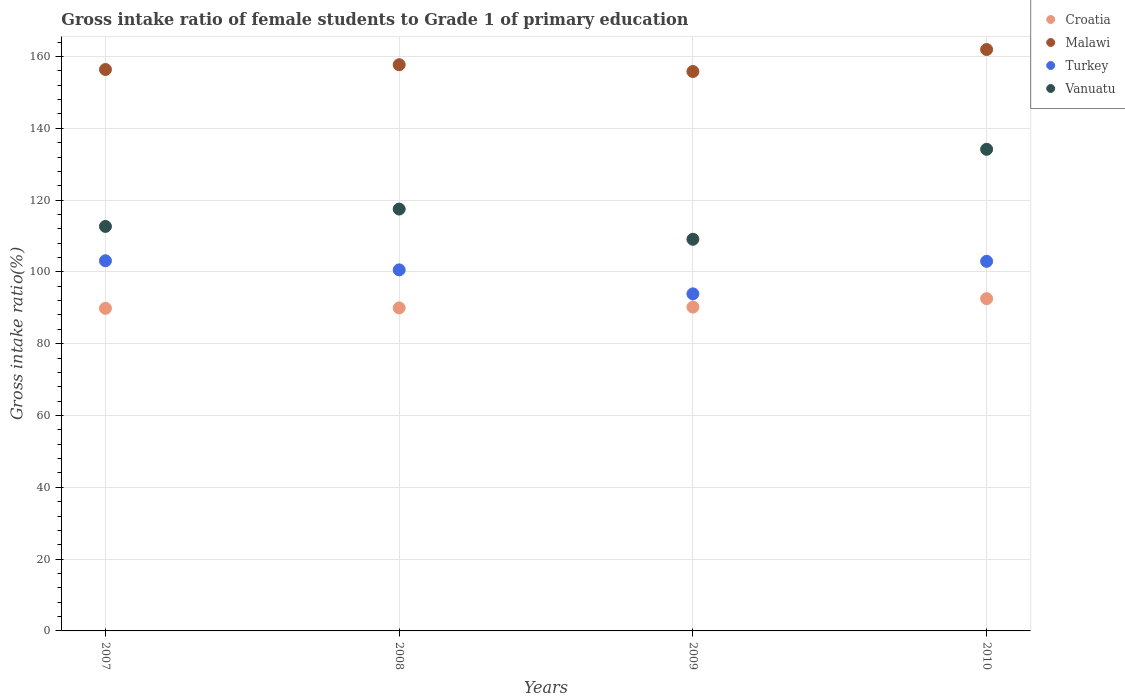What is the gross intake ratio in Vanuatu in 2007?
Your response must be concise. 112.67. Across all years, what is the maximum gross intake ratio in Turkey?
Ensure brevity in your answer.  103.11. Across all years, what is the minimum gross intake ratio in Vanuatu?
Your answer should be very brief. 109.09. What is the total gross intake ratio in Vanuatu in the graph?
Offer a terse response. 473.42. What is the difference between the gross intake ratio in Turkey in 2008 and that in 2010?
Provide a succinct answer. -2.38. What is the difference between the gross intake ratio in Croatia in 2009 and the gross intake ratio in Malawi in 2007?
Ensure brevity in your answer.  -66.18. What is the average gross intake ratio in Turkey per year?
Your answer should be very brief. 100.13. In the year 2007, what is the difference between the gross intake ratio in Malawi and gross intake ratio in Vanuatu?
Offer a very short reply. 43.71. What is the ratio of the gross intake ratio in Malawi in 2007 to that in 2010?
Ensure brevity in your answer.  0.97. Is the gross intake ratio in Vanuatu in 2008 less than that in 2009?
Make the answer very short. No. Is the difference between the gross intake ratio in Malawi in 2008 and 2009 greater than the difference between the gross intake ratio in Vanuatu in 2008 and 2009?
Give a very brief answer. No. What is the difference between the highest and the second highest gross intake ratio in Vanuatu?
Offer a very short reply. 16.64. What is the difference between the highest and the lowest gross intake ratio in Turkey?
Offer a terse response. 9.22. In how many years, is the gross intake ratio in Croatia greater than the average gross intake ratio in Croatia taken over all years?
Your answer should be very brief. 1. Is it the case that in every year, the sum of the gross intake ratio in Turkey and gross intake ratio in Malawi  is greater than the gross intake ratio in Croatia?
Provide a succinct answer. Yes. Does the gross intake ratio in Malawi monotonically increase over the years?
Your answer should be very brief. No. Is the gross intake ratio in Malawi strictly greater than the gross intake ratio in Croatia over the years?
Your answer should be very brief. Yes. Is the gross intake ratio in Vanuatu strictly less than the gross intake ratio in Croatia over the years?
Your answer should be compact. No. How many dotlines are there?
Provide a short and direct response. 4. How many years are there in the graph?
Offer a very short reply. 4. Are the values on the major ticks of Y-axis written in scientific E-notation?
Make the answer very short. No. Does the graph contain any zero values?
Give a very brief answer. No. How are the legend labels stacked?
Your answer should be very brief. Vertical. What is the title of the graph?
Your response must be concise. Gross intake ratio of female students to Grade 1 of primary education. What is the label or title of the X-axis?
Offer a very short reply. Years. What is the label or title of the Y-axis?
Your answer should be compact. Gross intake ratio(%). What is the Gross intake ratio(%) in Croatia in 2007?
Your response must be concise. 89.86. What is the Gross intake ratio(%) in Malawi in 2007?
Provide a short and direct response. 156.38. What is the Gross intake ratio(%) of Turkey in 2007?
Offer a terse response. 103.11. What is the Gross intake ratio(%) in Vanuatu in 2007?
Offer a very short reply. 112.67. What is the Gross intake ratio(%) of Croatia in 2008?
Provide a succinct answer. 89.97. What is the Gross intake ratio(%) in Malawi in 2008?
Ensure brevity in your answer.  157.71. What is the Gross intake ratio(%) of Turkey in 2008?
Offer a terse response. 100.57. What is the Gross intake ratio(%) in Vanuatu in 2008?
Provide a short and direct response. 117.51. What is the Gross intake ratio(%) in Croatia in 2009?
Offer a very short reply. 90.2. What is the Gross intake ratio(%) of Malawi in 2009?
Offer a very short reply. 155.82. What is the Gross intake ratio(%) of Turkey in 2009?
Provide a short and direct response. 93.89. What is the Gross intake ratio(%) in Vanuatu in 2009?
Give a very brief answer. 109.09. What is the Gross intake ratio(%) of Croatia in 2010?
Keep it short and to the point. 92.56. What is the Gross intake ratio(%) of Malawi in 2010?
Provide a short and direct response. 161.95. What is the Gross intake ratio(%) in Turkey in 2010?
Your response must be concise. 102.95. What is the Gross intake ratio(%) in Vanuatu in 2010?
Ensure brevity in your answer.  134.15. Across all years, what is the maximum Gross intake ratio(%) in Croatia?
Keep it short and to the point. 92.56. Across all years, what is the maximum Gross intake ratio(%) in Malawi?
Your response must be concise. 161.95. Across all years, what is the maximum Gross intake ratio(%) of Turkey?
Your response must be concise. 103.11. Across all years, what is the maximum Gross intake ratio(%) in Vanuatu?
Make the answer very short. 134.15. Across all years, what is the minimum Gross intake ratio(%) of Croatia?
Your answer should be compact. 89.86. Across all years, what is the minimum Gross intake ratio(%) in Malawi?
Keep it short and to the point. 155.82. Across all years, what is the minimum Gross intake ratio(%) in Turkey?
Make the answer very short. 93.89. Across all years, what is the minimum Gross intake ratio(%) of Vanuatu?
Keep it short and to the point. 109.09. What is the total Gross intake ratio(%) of Croatia in the graph?
Keep it short and to the point. 362.58. What is the total Gross intake ratio(%) of Malawi in the graph?
Offer a very short reply. 631.86. What is the total Gross intake ratio(%) of Turkey in the graph?
Offer a very short reply. 400.51. What is the total Gross intake ratio(%) of Vanuatu in the graph?
Keep it short and to the point. 473.42. What is the difference between the Gross intake ratio(%) of Croatia in 2007 and that in 2008?
Provide a short and direct response. -0.11. What is the difference between the Gross intake ratio(%) of Malawi in 2007 and that in 2008?
Give a very brief answer. -1.33. What is the difference between the Gross intake ratio(%) of Turkey in 2007 and that in 2008?
Keep it short and to the point. 2.54. What is the difference between the Gross intake ratio(%) of Vanuatu in 2007 and that in 2008?
Your response must be concise. -4.84. What is the difference between the Gross intake ratio(%) in Croatia in 2007 and that in 2009?
Make the answer very short. -0.34. What is the difference between the Gross intake ratio(%) of Malawi in 2007 and that in 2009?
Your answer should be compact. 0.56. What is the difference between the Gross intake ratio(%) of Turkey in 2007 and that in 2009?
Provide a succinct answer. 9.22. What is the difference between the Gross intake ratio(%) in Vanuatu in 2007 and that in 2009?
Offer a terse response. 3.58. What is the difference between the Gross intake ratio(%) of Croatia in 2007 and that in 2010?
Provide a succinct answer. -2.7. What is the difference between the Gross intake ratio(%) in Malawi in 2007 and that in 2010?
Keep it short and to the point. -5.56. What is the difference between the Gross intake ratio(%) in Turkey in 2007 and that in 2010?
Your answer should be very brief. 0.16. What is the difference between the Gross intake ratio(%) in Vanuatu in 2007 and that in 2010?
Ensure brevity in your answer.  -21.48. What is the difference between the Gross intake ratio(%) in Croatia in 2008 and that in 2009?
Offer a terse response. -0.24. What is the difference between the Gross intake ratio(%) in Malawi in 2008 and that in 2009?
Make the answer very short. 1.89. What is the difference between the Gross intake ratio(%) in Turkey in 2008 and that in 2009?
Ensure brevity in your answer.  6.68. What is the difference between the Gross intake ratio(%) in Vanuatu in 2008 and that in 2009?
Make the answer very short. 8.42. What is the difference between the Gross intake ratio(%) in Croatia in 2008 and that in 2010?
Offer a terse response. -2.59. What is the difference between the Gross intake ratio(%) of Malawi in 2008 and that in 2010?
Provide a succinct answer. -4.23. What is the difference between the Gross intake ratio(%) of Turkey in 2008 and that in 2010?
Offer a terse response. -2.38. What is the difference between the Gross intake ratio(%) in Vanuatu in 2008 and that in 2010?
Your answer should be compact. -16.64. What is the difference between the Gross intake ratio(%) in Croatia in 2009 and that in 2010?
Give a very brief answer. -2.35. What is the difference between the Gross intake ratio(%) of Malawi in 2009 and that in 2010?
Provide a succinct answer. -6.13. What is the difference between the Gross intake ratio(%) of Turkey in 2009 and that in 2010?
Provide a short and direct response. -9.06. What is the difference between the Gross intake ratio(%) in Vanuatu in 2009 and that in 2010?
Give a very brief answer. -25.07. What is the difference between the Gross intake ratio(%) of Croatia in 2007 and the Gross intake ratio(%) of Malawi in 2008?
Make the answer very short. -67.85. What is the difference between the Gross intake ratio(%) of Croatia in 2007 and the Gross intake ratio(%) of Turkey in 2008?
Your response must be concise. -10.71. What is the difference between the Gross intake ratio(%) in Croatia in 2007 and the Gross intake ratio(%) in Vanuatu in 2008?
Keep it short and to the point. -27.65. What is the difference between the Gross intake ratio(%) in Malawi in 2007 and the Gross intake ratio(%) in Turkey in 2008?
Your response must be concise. 55.82. What is the difference between the Gross intake ratio(%) in Malawi in 2007 and the Gross intake ratio(%) in Vanuatu in 2008?
Your response must be concise. 38.87. What is the difference between the Gross intake ratio(%) of Turkey in 2007 and the Gross intake ratio(%) of Vanuatu in 2008?
Give a very brief answer. -14.4. What is the difference between the Gross intake ratio(%) of Croatia in 2007 and the Gross intake ratio(%) of Malawi in 2009?
Provide a succinct answer. -65.96. What is the difference between the Gross intake ratio(%) in Croatia in 2007 and the Gross intake ratio(%) in Turkey in 2009?
Offer a very short reply. -4.03. What is the difference between the Gross intake ratio(%) in Croatia in 2007 and the Gross intake ratio(%) in Vanuatu in 2009?
Keep it short and to the point. -19.23. What is the difference between the Gross intake ratio(%) of Malawi in 2007 and the Gross intake ratio(%) of Turkey in 2009?
Keep it short and to the point. 62.49. What is the difference between the Gross intake ratio(%) in Malawi in 2007 and the Gross intake ratio(%) in Vanuatu in 2009?
Provide a succinct answer. 47.3. What is the difference between the Gross intake ratio(%) in Turkey in 2007 and the Gross intake ratio(%) in Vanuatu in 2009?
Your answer should be very brief. -5.98. What is the difference between the Gross intake ratio(%) in Croatia in 2007 and the Gross intake ratio(%) in Malawi in 2010?
Keep it short and to the point. -72.09. What is the difference between the Gross intake ratio(%) of Croatia in 2007 and the Gross intake ratio(%) of Turkey in 2010?
Provide a short and direct response. -13.09. What is the difference between the Gross intake ratio(%) of Croatia in 2007 and the Gross intake ratio(%) of Vanuatu in 2010?
Your answer should be very brief. -44.29. What is the difference between the Gross intake ratio(%) in Malawi in 2007 and the Gross intake ratio(%) in Turkey in 2010?
Your response must be concise. 53.43. What is the difference between the Gross intake ratio(%) of Malawi in 2007 and the Gross intake ratio(%) of Vanuatu in 2010?
Ensure brevity in your answer.  22.23. What is the difference between the Gross intake ratio(%) in Turkey in 2007 and the Gross intake ratio(%) in Vanuatu in 2010?
Offer a very short reply. -31.05. What is the difference between the Gross intake ratio(%) of Croatia in 2008 and the Gross intake ratio(%) of Malawi in 2009?
Keep it short and to the point. -65.85. What is the difference between the Gross intake ratio(%) of Croatia in 2008 and the Gross intake ratio(%) of Turkey in 2009?
Provide a short and direct response. -3.92. What is the difference between the Gross intake ratio(%) in Croatia in 2008 and the Gross intake ratio(%) in Vanuatu in 2009?
Keep it short and to the point. -19.12. What is the difference between the Gross intake ratio(%) of Malawi in 2008 and the Gross intake ratio(%) of Turkey in 2009?
Ensure brevity in your answer.  63.82. What is the difference between the Gross intake ratio(%) of Malawi in 2008 and the Gross intake ratio(%) of Vanuatu in 2009?
Offer a very short reply. 48.63. What is the difference between the Gross intake ratio(%) in Turkey in 2008 and the Gross intake ratio(%) in Vanuatu in 2009?
Provide a short and direct response. -8.52. What is the difference between the Gross intake ratio(%) in Croatia in 2008 and the Gross intake ratio(%) in Malawi in 2010?
Offer a very short reply. -71.98. What is the difference between the Gross intake ratio(%) of Croatia in 2008 and the Gross intake ratio(%) of Turkey in 2010?
Provide a short and direct response. -12.98. What is the difference between the Gross intake ratio(%) of Croatia in 2008 and the Gross intake ratio(%) of Vanuatu in 2010?
Keep it short and to the point. -44.19. What is the difference between the Gross intake ratio(%) of Malawi in 2008 and the Gross intake ratio(%) of Turkey in 2010?
Ensure brevity in your answer.  54.76. What is the difference between the Gross intake ratio(%) of Malawi in 2008 and the Gross intake ratio(%) of Vanuatu in 2010?
Your answer should be compact. 23.56. What is the difference between the Gross intake ratio(%) in Turkey in 2008 and the Gross intake ratio(%) in Vanuatu in 2010?
Keep it short and to the point. -33.59. What is the difference between the Gross intake ratio(%) of Croatia in 2009 and the Gross intake ratio(%) of Malawi in 2010?
Make the answer very short. -71.74. What is the difference between the Gross intake ratio(%) in Croatia in 2009 and the Gross intake ratio(%) in Turkey in 2010?
Your response must be concise. -12.75. What is the difference between the Gross intake ratio(%) in Croatia in 2009 and the Gross intake ratio(%) in Vanuatu in 2010?
Your answer should be very brief. -43.95. What is the difference between the Gross intake ratio(%) of Malawi in 2009 and the Gross intake ratio(%) of Turkey in 2010?
Ensure brevity in your answer.  52.87. What is the difference between the Gross intake ratio(%) in Malawi in 2009 and the Gross intake ratio(%) in Vanuatu in 2010?
Your answer should be very brief. 21.67. What is the difference between the Gross intake ratio(%) in Turkey in 2009 and the Gross intake ratio(%) in Vanuatu in 2010?
Your answer should be compact. -40.26. What is the average Gross intake ratio(%) of Croatia per year?
Make the answer very short. 90.65. What is the average Gross intake ratio(%) in Malawi per year?
Your answer should be very brief. 157.97. What is the average Gross intake ratio(%) in Turkey per year?
Offer a terse response. 100.13. What is the average Gross intake ratio(%) in Vanuatu per year?
Your answer should be compact. 118.36. In the year 2007, what is the difference between the Gross intake ratio(%) in Croatia and Gross intake ratio(%) in Malawi?
Ensure brevity in your answer.  -66.52. In the year 2007, what is the difference between the Gross intake ratio(%) of Croatia and Gross intake ratio(%) of Turkey?
Offer a terse response. -13.25. In the year 2007, what is the difference between the Gross intake ratio(%) in Croatia and Gross intake ratio(%) in Vanuatu?
Make the answer very short. -22.81. In the year 2007, what is the difference between the Gross intake ratio(%) of Malawi and Gross intake ratio(%) of Turkey?
Offer a terse response. 53.28. In the year 2007, what is the difference between the Gross intake ratio(%) in Malawi and Gross intake ratio(%) in Vanuatu?
Your response must be concise. 43.71. In the year 2007, what is the difference between the Gross intake ratio(%) in Turkey and Gross intake ratio(%) in Vanuatu?
Your answer should be compact. -9.57. In the year 2008, what is the difference between the Gross intake ratio(%) of Croatia and Gross intake ratio(%) of Malawi?
Provide a short and direct response. -67.75. In the year 2008, what is the difference between the Gross intake ratio(%) of Croatia and Gross intake ratio(%) of Turkey?
Offer a terse response. -10.6. In the year 2008, what is the difference between the Gross intake ratio(%) in Croatia and Gross intake ratio(%) in Vanuatu?
Your answer should be very brief. -27.54. In the year 2008, what is the difference between the Gross intake ratio(%) in Malawi and Gross intake ratio(%) in Turkey?
Offer a very short reply. 57.15. In the year 2008, what is the difference between the Gross intake ratio(%) in Malawi and Gross intake ratio(%) in Vanuatu?
Your answer should be compact. 40.2. In the year 2008, what is the difference between the Gross intake ratio(%) in Turkey and Gross intake ratio(%) in Vanuatu?
Give a very brief answer. -16.94. In the year 2009, what is the difference between the Gross intake ratio(%) in Croatia and Gross intake ratio(%) in Malawi?
Your answer should be very brief. -65.62. In the year 2009, what is the difference between the Gross intake ratio(%) in Croatia and Gross intake ratio(%) in Turkey?
Provide a short and direct response. -3.69. In the year 2009, what is the difference between the Gross intake ratio(%) in Croatia and Gross intake ratio(%) in Vanuatu?
Make the answer very short. -18.89. In the year 2009, what is the difference between the Gross intake ratio(%) in Malawi and Gross intake ratio(%) in Turkey?
Provide a succinct answer. 61.93. In the year 2009, what is the difference between the Gross intake ratio(%) in Malawi and Gross intake ratio(%) in Vanuatu?
Your answer should be very brief. 46.73. In the year 2009, what is the difference between the Gross intake ratio(%) in Turkey and Gross intake ratio(%) in Vanuatu?
Offer a terse response. -15.2. In the year 2010, what is the difference between the Gross intake ratio(%) of Croatia and Gross intake ratio(%) of Malawi?
Your answer should be very brief. -69.39. In the year 2010, what is the difference between the Gross intake ratio(%) in Croatia and Gross intake ratio(%) in Turkey?
Provide a short and direct response. -10.39. In the year 2010, what is the difference between the Gross intake ratio(%) in Croatia and Gross intake ratio(%) in Vanuatu?
Give a very brief answer. -41.6. In the year 2010, what is the difference between the Gross intake ratio(%) in Malawi and Gross intake ratio(%) in Turkey?
Provide a short and direct response. 59. In the year 2010, what is the difference between the Gross intake ratio(%) in Malawi and Gross intake ratio(%) in Vanuatu?
Offer a very short reply. 27.79. In the year 2010, what is the difference between the Gross intake ratio(%) in Turkey and Gross intake ratio(%) in Vanuatu?
Offer a very short reply. -31.2. What is the ratio of the Gross intake ratio(%) of Croatia in 2007 to that in 2008?
Your response must be concise. 1. What is the ratio of the Gross intake ratio(%) of Turkey in 2007 to that in 2008?
Your answer should be compact. 1.03. What is the ratio of the Gross intake ratio(%) of Vanuatu in 2007 to that in 2008?
Provide a succinct answer. 0.96. What is the ratio of the Gross intake ratio(%) of Malawi in 2007 to that in 2009?
Provide a short and direct response. 1. What is the ratio of the Gross intake ratio(%) in Turkey in 2007 to that in 2009?
Give a very brief answer. 1.1. What is the ratio of the Gross intake ratio(%) in Vanuatu in 2007 to that in 2009?
Ensure brevity in your answer.  1.03. What is the ratio of the Gross intake ratio(%) of Croatia in 2007 to that in 2010?
Keep it short and to the point. 0.97. What is the ratio of the Gross intake ratio(%) of Malawi in 2007 to that in 2010?
Offer a terse response. 0.97. What is the ratio of the Gross intake ratio(%) in Turkey in 2007 to that in 2010?
Offer a very short reply. 1. What is the ratio of the Gross intake ratio(%) in Vanuatu in 2007 to that in 2010?
Provide a short and direct response. 0.84. What is the ratio of the Gross intake ratio(%) in Croatia in 2008 to that in 2009?
Offer a terse response. 1. What is the ratio of the Gross intake ratio(%) of Malawi in 2008 to that in 2009?
Your response must be concise. 1.01. What is the ratio of the Gross intake ratio(%) in Turkey in 2008 to that in 2009?
Provide a succinct answer. 1.07. What is the ratio of the Gross intake ratio(%) in Vanuatu in 2008 to that in 2009?
Provide a short and direct response. 1.08. What is the ratio of the Gross intake ratio(%) of Croatia in 2008 to that in 2010?
Offer a terse response. 0.97. What is the ratio of the Gross intake ratio(%) of Malawi in 2008 to that in 2010?
Your answer should be very brief. 0.97. What is the ratio of the Gross intake ratio(%) of Turkey in 2008 to that in 2010?
Provide a short and direct response. 0.98. What is the ratio of the Gross intake ratio(%) of Vanuatu in 2008 to that in 2010?
Provide a short and direct response. 0.88. What is the ratio of the Gross intake ratio(%) of Croatia in 2009 to that in 2010?
Provide a short and direct response. 0.97. What is the ratio of the Gross intake ratio(%) of Malawi in 2009 to that in 2010?
Offer a very short reply. 0.96. What is the ratio of the Gross intake ratio(%) in Turkey in 2009 to that in 2010?
Your answer should be compact. 0.91. What is the ratio of the Gross intake ratio(%) of Vanuatu in 2009 to that in 2010?
Your answer should be very brief. 0.81. What is the difference between the highest and the second highest Gross intake ratio(%) in Croatia?
Your answer should be compact. 2.35. What is the difference between the highest and the second highest Gross intake ratio(%) in Malawi?
Provide a succinct answer. 4.23. What is the difference between the highest and the second highest Gross intake ratio(%) in Turkey?
Your answer should be compact. 0.16. What is the difference between the highest and the second highest Gross intake ratio(%) in Vanuatu?
Provide a succinct answer. 16.64. What is the difference between the highest and the lowest Gross intake ratio(%) of Croatia?
Give a very brief answer. 2.7. What is the difference between the highest and the lowest Gross intake ratio(%) of Malawi?
Provide a succinct answer. 6.13. What is the difference between the highest and the lowest Gross intake ratio(%) of Turkey?
Your answer should be compact. 9.22. What is the difference between the highest and the lowest Gross intake ratio(%) in Vanuatu?
Make the answer very short. 25.07. 